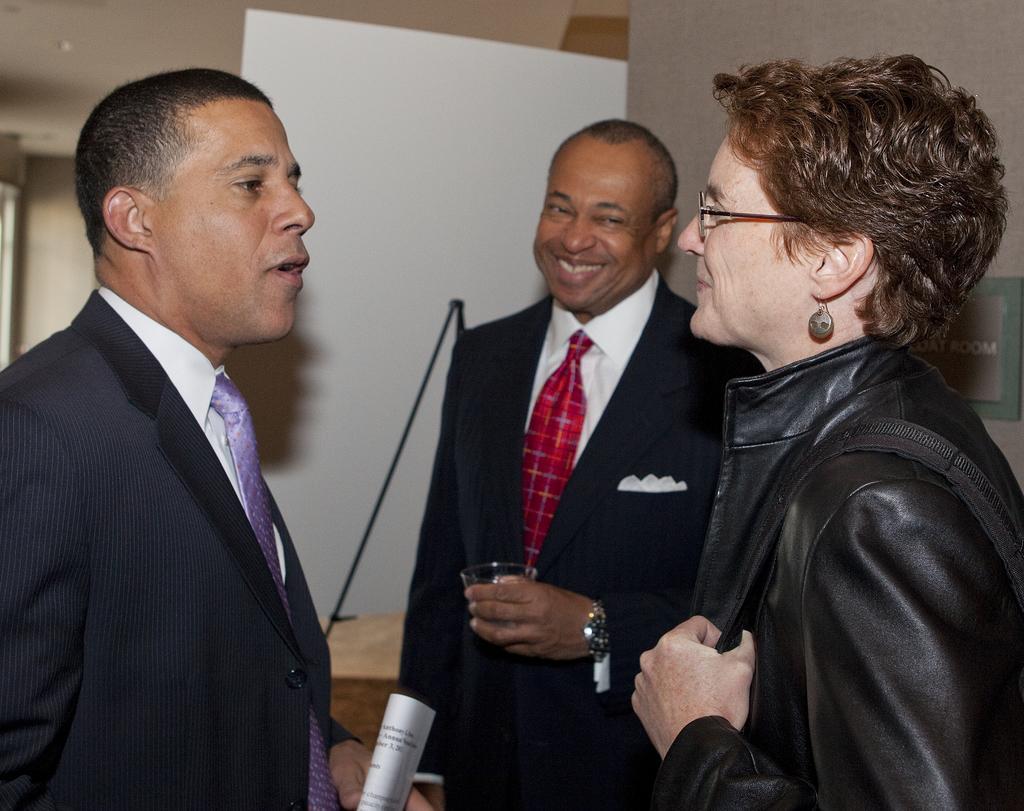Describe this image in one or two sentences. In this picture there is a person standing and smiling and there is a person standing and smiling and holding the glass and there is a person standing and holding the paper. At the back there is a board. On the right side of the image there is a board on the wall and there is a text on the board. 